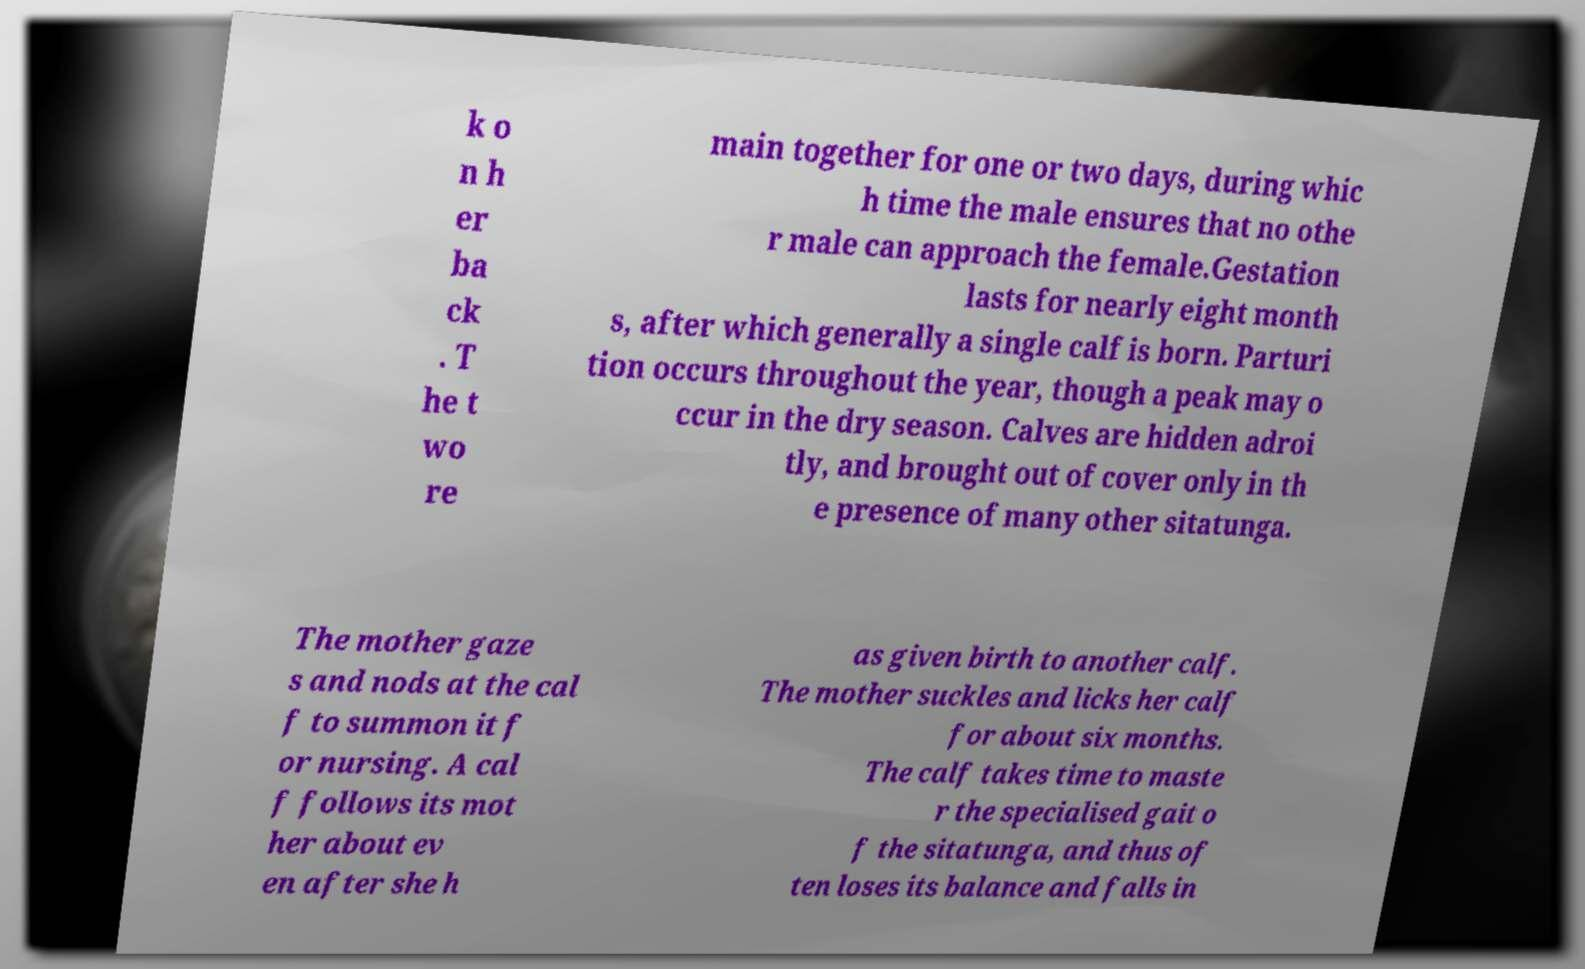Can you read and provide the text displayed in the image?This photo seems to have some interesting text. Can you extract and type it out for me? k o n h er ba ck . T he t wo re main together for one or two days, during whic h time the male ensures that no othe r male can approach the female.Gestation lasts for nearly eight month s, after which generally a single calf is born. Parturi tion occurs throughout the year, though a peak may o ccur in the dry season. Calves are hidden adroi tly, and brought out of cover only in th e presence of many other sitatunga. The mother gaze s and nods at the cal f to summon it f or nursing. A cal f follows its mot her about ev en after she h as given birth to another calf. The mother suckles and licks her calf for about six months. The calf takes time to maste r the specialised gait o f the sitatunga, and thus of ten loses its balance and falls in 